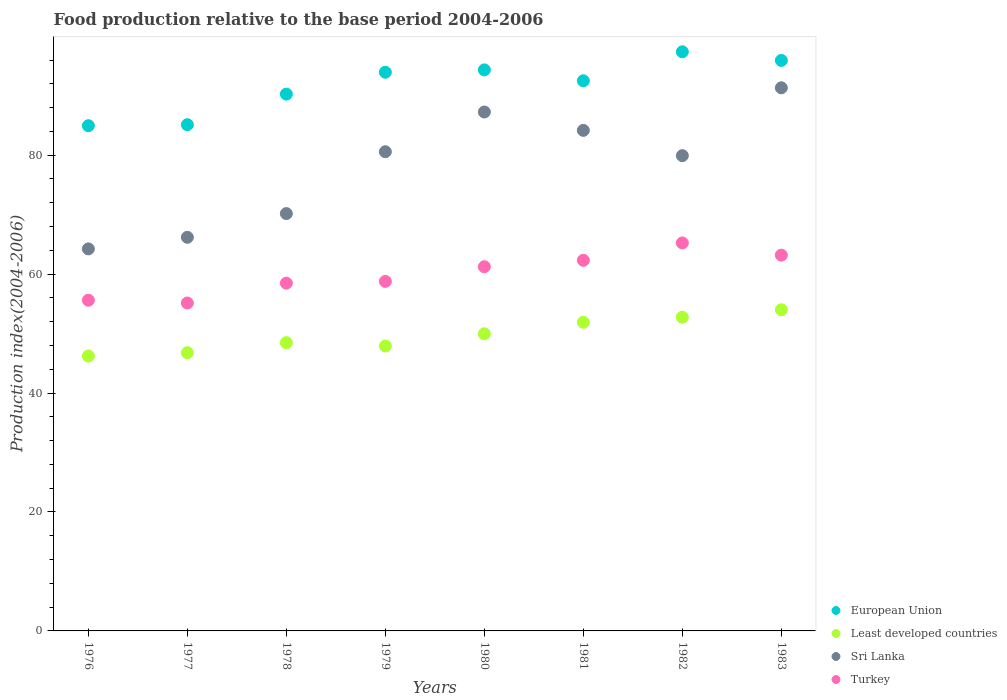How many different coloured dotlines are there?
Offer a very short reply. 4. What is the food production index in European Union in 1981?
Your answer should be compact. 92.51. Across all years, what is the maximum food production index in Least developed countries?
Make the answer very short. 54.01. Across all years, what is the minimum food production index in Turkey?
Your answer should be very brief. 55.14. In which year was the food production index in Least developed countries maximum?
Make the answer very short. 1983. In which year was the food production index in Least developed countries minimum?
Keep it short and to the point. 1976. What is the total food production index in Sri Lanka in the graph?
Your response must be concise. 623.87. What is the difference between the food production index in Turkey in 1977 and that in 1982?
Your response must be concise. -10.1. What is the difference between the food production index in Least developed countries in 1978 and the food production index in Turkey in 1977?
Provide a short and direct response. -6.67. What is the average food production index in Sri Lanka per year?
Make the answer very short. 77.98. In the year 1976, what is the difference between the food production index in Turkey and food production index in Sri Lanka?
Make the answer very short. -8.63. What is the ratio of the food production index in Sri Lanka in 1980 to that in 1983?
Offer a very short reply. 0.96. What is the difference between the highest and the second highest food production index in Sri Lanka?
Offer a terse response. 4.07. What is the difference between the highest and the lowest food production index in Least developed countries?
Ensure brevity in your answer.  7.78. Is the sum of the food production index in Least developed countries in 1976 and 1982 greater than the maximum food production index in Turkey across all years?
Offer a terse response. Yes. Is it the case that in every year, the sum of the food production index in Least developed countries and food production index in Turkey  is greater than the sum of food production index in European Union and food production index in Sri Lanka?
Offer a very short reply. No. Does the food production index in European Union monotonically increase over the years?
Provide a short and direct response. No. Is the food production index in Turkey strictly greater than the food production index in Least developed countries over the years?
Provide a succinct answer. Yes. How many years are there in the graph?
Your answer should be very brief. 8. What is the difference between two consecutive major ticks on the Y-axis?
Offer a terse response. 20. Are the values on the major ticks of Y-axis written in scientific E-notation?
Provide a short and direct response. No. How many legend labels are there?
Offer a very short reply. 4. What is the title of the graph?
Offer a very short reply. Food production relative to the base period 2004-2006. Does "Madagascar" appear as one of the legend labels in the graph?
Keep it short and to the point. No. What is the label or title of the X-axis?
Ensure brevity in your answer.  Years. What is the label or title of the Y-axis?
Your answer should be compact. Production index(2004-2006). What is the Production index(2004-2006) of European Union in 1976?
Your response must be concise. 84.96. What is the Production index(2004-2006) of Least developed countries in 1976?
Your answer should be very brief. 46.23. What is the Production index(2004-2006) of Sri Lanka in 1976?
Ensure brevity in your answer.  64.24. What is the Production index(2004-2006) of Turkey in 1976?
Give a very brief answer. 55.61. What is the Production index(2004-2006) in European Union in 1977?
Keep it short and to the point. 85.13. What is the Production index(2004-2006) in Least developed countries in 1977?
Offer a terse response. 46.79. What is the Production index(2004-2006) in Sri Lanka in 1977?
Offer a very short reply. 66.19. What is the Production index(2004-2006) of Turkey in 1977?
Offer a very short reply. 55.14. What is the Production index(2004-2006) in European Union in 1978?
Provide a succinct answer. 90.27. What is the Production index(2004-2006) of Least developed countries in 1978?
Give a very brief answer. 48.47. What is the Production index(2004-2006) of Sri Lanka in 1978?
Provide a succinct answer. 70.18. What is the Production index(2004-2006) of Turkey in 1978?
Offer a terse response. 58.48. What is the Production index(2004-2006) of European Union in 1979?
Your answer should be very brief. 93.95. What is the Production index(2004-2006) in Least developed countries in 1979?
Your response must be concise. 47.9. What is the Production index(2004-2006) in Sri Lanka in 1979?
Your answer should be very brief. 80.58. What is the Production index(2004-2006) of Turkey in 1979?
Offer a very short reply. 58.78. What is the Production index(2004-2006) in European Union in 1980?
Offer a terse response. 94.34. What is the Production index(2004-2006) in Least developed countries in 1980?
Your answer should be compact. 49.97. What is the Production index(2004-2006) of Sri Lanka in 1980?
Your answer should be compact. 87.26. What is the Production index(2004-2006) of Turkey in 1980?
Offer a terse response. 61.24. What is the Production index(2004-2006) of European Union in 1981?
Provide a short and direct response. 92.51. What is the Production index(2004-2006) in Least developed countries in 1981?
Provide a succinct answer. 51.9. What is the Production index(2004-2006) of Sri Lanka in 1981?
Offer a terse response. 84.17. What is the Production index(2004-2006) of Turkey in 1981?
Your answer should be compact. 62.32. What is the Production index(2004-2006) of European Union in 1982?
Provide a short and direct response. 97.39. What is the Production index(2004-2006) of Least developed countries in 1982?
Offer a terse response. 52.75. What is the Production index(2004-2006) in Sri Lanka in 1982?
Provide a short and direct response. 79.92. What is the Production index(2004-2006) of Turkey in 1982?
Provide a succinct answer. 65.24. What is the Production index(2004-2006) in European Union in 1983?
Give a very brief answer. 95.93. What is the Production index(2004-2006) of Least developed countries in 1983?
Offer a very short reply. 54.01. What is the Production index(2004-2006) in Sri Lanka in 1983?
Offer a terse response. 91.33. What is the Production index(2004-2006) of Turkey in 1983?
Your response must be concise. 63.19. Across all years, what is the maximum Production index(2004-2006) of European Union?
Your answer should be compact. 97.39. Across all years, what is the maximum Production index(2004-2006) in Least developed countries?
Offer a very short reply. 54.01. Across all years, what is the maximum Production index(2004-2006) in Sri Lanka?
Keep it short and to the point. 91.33. Across all years, what is the maximum Production index(2004-2006) in Turkey?
Offer a terse response. 65.24. Across all years, what is the minimum Production index(2004-2006) in European Union?
Make the answer very short. 84.96. Across all years, what is the minimum Production index(2004-2006) of Least developed countries?
Keep it short and to the point. 46.23. Across all years, what is the minimum Production index(2004-2006) in Sri Lanka?
Keep it short and to the point. 64.24. Across all years, what is the minimum Production index(2004-2006) in Turkey?
Your answer should be very brief. 55.14. What is the total Production index(2004-2006) of European Union in the graph?
Keep it short and to the point. 734.47. What is the total Production index(2004-2006) in Least developed countries in the graph?
Offer a terse response. 398.02. What is the total Production index(2004-2006) in Sri Lanka in the graph?
Your answer should be very brief. 623.87. What is the total Production index(2004-2006) of Turkey in the graph?
Provide a short and direct response. 480. What is the difference between the Production index(2004-2006) of European Union in 1976 and that in 1977?
Your answer should be compact. -0.17. What is the difference between the Production index(2004-2006) of Least developed countries in 1976 and that in 1977?
Ensure brevity in your answer.  -0.56. What is the difference between the Production index(2004-2006) in Sri Lanka in 1976 and that in 1977?
Make the answer very short. -1.95. What is the difference between the Production index(2004-2006) of Turkey in 1976 and that in 1977?
Your answer should be very brief. 0.47. What is the difference between the Production index(2004-2006) of European Union in 1976 and that in 1978?
Provide a short and direct response. -5.31. What is the difference between the Production index(2004-2006) of Least developed countries in 1976 and that in 1978?
Provide a short and direct response. -2.24. What is the difference between the Production index(2004-2006) in Sri Lanka in 1976 and that in 1978?
Your answer should be very brief. -5.94. What is the difference between the Production index(2004-2006) in Turkey in 1976 and that in 1978?
Provide a short and direct response. -2.87. What is the difference between the Production index(2004-2006) in European Union in 1976 and that in 1979?
Your answer should be very brief. -8.99. What is the difference between the Production index(2004-2006) in Least developed countries in 1976 and that in 1979?
Your answer should be very brief. -1.67. What is the difference between the Production index(2004-2006) in Sri Lanka in 1976 and that in 1979?
Ensure brevity in your answer.  -16.34. What is the difference between the Production index(2004-2006) of Turkey in 1976 and that in 1979?
Offer a terse response. -3.17. What is the difference between the Production index(2004-2006) of European Union in 1976 and that in 1980?
Provide a short and direct response. -9.39. What is the difference between the Production index(2004-2006) in Least developed countries in 1976 and that in 1980?
Give a very brief answer. -3.74. What is the difference between the Production index(2004-2006) in Sri Lanka in 1976 and that in 1980?
Keep it short and to the point. -23.02. What is the difference between the Production index(2004-2006) in Turkey in 1976 and that in 1980?
Make the answer very short. -5.63. What is the difference between the Production index(2004-2006) of European Union in 1976 and that in 1981?
Make the answer very short. -7.55. What is the difference between the Production index(2004-2006) in Least developed countries in 1976 and that in 1981?
Your response must be concise. -5.67. What is the difference between the Production index(2004-2006) of Sri Lanka in 1976 and that in 1981?
Make the answer very short. -19.93. What is the difference between the Production index(2004-2006) in Turkey in 1976 and that in 1981?
Your response must be concise. -6.71. What is the difference between the Production index(2004-2006) of European Union in 1976 and that in 1982?
Ensure brevity in your answer.  -12.43. What is the difference between the Production index(2004-2006) of Least developed countries in 1976 and that in 1982?
Your answer should be very brief. -6.52. What is the difference between the Production index(2004-2006) of Sri Lanka in 1976 and that in 1982?
Offer a very short reply. -15.68. What is the difference between the Production index(2004-2006) in Turkey in 1976 and that in 1982?
Give a very brief answer. -9.63. What is the difference between the Production index(2004-2006) of European Union in 1976 and that in 1983?
Keep it short and to the point. -10.98. What is the difference between the Production index(2004-2006) of Least developed countries in 1976 and that in 1983?
Keep it short and to the point. -7.78. What is the difference between the Production index(2004-2006) in Sri Lanka in 1976 and that in 1983?
Your answer should be very brief. -27.09. What is the difference between the Production index(2004-2006) of Turkey in 1976 and that in 1983?
Make the answer very short. -7.58. What is the difference between the Production index(2004-2006) in European Union in 1977 and that in 1978?
Provide a succinct answer. -5.14. What is the difference between the Production index(2004-2006) in Least developed countries in 1977 and that in 1978?
Make the answer very short. -1.69. What is the difference between the Production index(2004-2006) of Sri Lanka in 1977 and that in 1978?
Offer a very short reply. -3.99. What is the difference between the Production index(2004-2006) in Turkey in 1977 and that in 1978?
Give a very brief answer. -3.34. What is the difference between the Production index(2004-2006) in European Union in 1977 and that in 1979?
Your answer should be compact. -8.82. What is the difference between the Production index(2004-2006) in Least developed countries in 1977 and that in 1979?
Offer a very short reply. -1.11. What is the difference between the Production index(2004-2006) of Sri Lanka in 1977 and that in 1979?
Your response must be concise. -14.39. What is the difference between the Production index(2004-2006) in Turkey in 1977 and that in 1979?
Your answer should be very brief. -3.64. What is the difference between the Production index(2004-2006) in European Union in 1977 and that in 1980?
Offer a very short reply. -9.22. What is the difference between the Production index(2004-2006) of Least developed countries in 1977 and that in 1980?
Provide a succinct answer. -3.18. What is the difference between the Production index(2004-2006) of Sri Lanka in 1977 and that in 1980?
Provide a short and direct response. -21.07. What is the difference between the Production index(2004-2006) in Turkey in 1977 and that in 1980?
Provide a short and direct response. -6.1. What is the difference between the Production index(2004-2006) of European Union in 1977 and that in 1981?
Your answer should be compact. -7.38. What is the difference between the Production index(2004-2006) in Least developed countries in 1977 and that in 1981?
Ensure brevity in your answer.  -5.11. What is the difference between the Production index(2004-2006) of Sri Lanka in 1977 and that in 1981?
Your answer should be compact. -17.98. What is the difference between the Production index(2004-2006) in Turkey in 1977 and that in 1981?
Your answer should be very brief. -7.18. What is the difference between the Production index(2004-2006) in European Union in 1977 and that in 1982?
Give a very brief answer. -12.26. What is the difference between the Production index(2004-2006) of Least developed countries in 1977 and that in 1982?
Offer a very short reply. -5.96. What is the difference between the Production index(2004-2006) in Sri Lanka in 1977 and that in 1982?
Keep it short and to the point. -13.73. What is the difference between the Production index(2004-2006) of European Union in 1977 and that in 1983?
Your response must be concise. -10.81. What is the difference between the Production index(2004-2006) in Least developed countries in 1977 and that in 1983?
Your answer should be compact. -7.22. What is the difference between the Production index(2004-2006) in Sri Lanka in 1977 and that in 1983?
Your response must be concise. -25.14. What is the difference between the Production index(2004-2006) in Turkey in 1977 and that in 1983?
Ensure brevity in your answer.  -8.05. What is the difference between the Production index(2004-2006) in European Union in 1978 and that in 1979?
Provide a short and direct response. -3.68. What is the difference between the Production index(2004-2006) in Least developed countries in 1978 and that in 1979?
Provide a short and direct response. 0.57. What is the difference between the Production index(2004-2006) of Sri Lanka in 1978 and that in 1979?
Give a very brief answer. -10.4. What is the difference between the Production index(2004-2006) in European Union in 1978 and that in 1980?
Offer a very short reply. -4.08. What is the difference between the Production index(2004-2006) of Least developed countries in 1978 and that in 1980?
Provide a short and direct response. -1.49. What is the difference between the Production index(2004-2006) of Sri Lanka in 1978 and that in 1980?
Give a very brief answer. -17.08. What is the difference between the Production index(2004-2006) in Turkey in 1978 and that in 1980?
Give a very brief answer. -2.76. What is the difference between the Production index(2004-2006) in European Union in 1978 and that in 1981?
Ensure brevity in your answer.  -2.24. What is the difference between the Production index(2004-2006) of Least developed countries in 1978 and that in 1981?
Offer a terse response. -3.43. What is the difference between the Production index(2004-2006) in Sri Lanka in 1978 and that in 1981?
Keep it short and to the point. -13.99. What is the difference between the Production index(2004-2006) in Turkey in 1978 and that in 1981?
Your answer should be very brief. -3.84. What is the difference between the Production index(2004-2006) of European Union in 1978 and that in 1982?
Your response must be concise. -7.12. What is the difference between the Production index(2004-2006) of Least developed countries in 1978 and that in 1982?
Give a very brief answer. -4.28. What is the difference between the Production index(2004-2006) in Sri Lanka in 1978 and that in 1982?
Your answer should be very brief. -9.74. What is the difference between the Production index(2004-2006) in Turkey in 1978 and that in 1982?
Keep it short and to the point. -6.76. What is the difference between the Production index(2004-2006) of European Union in 1978 and that in 1983?
Give a very brief answer. -5.66. What is the difference between the Production index(2004-2006) in Least developed countries in 1978 and that in 1983?
Your answer should be compact. -5.53. What is the difference between the Production index(2004-2006) in Sri Lanka in 1978 and that in 1983?
Offer a very short reply. -21.15. What is the difference between the Production index(2004-2006) of Turkey in 1978 and that in 1983?
Ensure brevity in your answer.  -4.71. What is the difference between the Production index(2004-2006) in European Union in 1979 and that in 1980?
Your answer should be very brief. -0.4. What is the difference between the Production index(2004-2006) of Least developed countries in 1979 and that in 1980?
Your answer should be compact. -2.07. What is the difference between the Production index(2004-2006) of Sri Lanka in 1979 and that in 1980?
Your response must be concise. -6.68. What is the difference between the Production index(2004-2006) of Turkey in 1979 and that in 1980?
Offer a very short reply. -2.46. What is the difference between the Production index(2004-2006) of European Union in 1979 and that in 1981?
Give a very brief answer. 1.44. What is the difference between the Production index(2004-2006) of Least developed countries in 1979 and that in 1981?
Your answer should be compact. -4. What is the difference between the Production index(2004-2006) in Sri Lanka in 1979 and that in 1981?
Provide a short and direct response. -3.59. What is the difference between the Production index(2004-2006) of Turkey in 1979 and that in 1981?
Give a very brief answer. -3.54. What is the difference between the Production index(2004-2006) in European Union in 1979 and that in 1982?
Your answer should be very brief. -3.44. What is the difference between the Production index(2004-2006) of Least developed countries in 1979 and that in 1982?
Your response must be concise. -4.85. What is the difference between the Production index(2004-2006) of Sri Lanka in 1979 and that in 1982?
Provide a short and direct response. 0.66. What is the difference between the Production index(2004-2006) in Turkey in 1979 and that in 1982?
Your response must be concise. -6.46. What is the difference between the Production index(2004-2006) of European Union in 1979 and that in 1983?
Your answer should be very brief. -1.99. What is the difference between the Production index(2004-2006) of Least developed countries in 1979 and that in 1983?
Give a very brief answer. -6.11. What is the difference between the Production index(2004-2006) of Sri Lanka in 1979 and that in 1983?
Offer a terse response. -10.75. What is the difference between the Production index(2004-2006) in Turkey in 1979 and that in 1983?
Offer a very short reply. -4.41. What is the difference between the Production index(2004-2006) of European Union in 1980 and that in 1981?
Provide a short and direct response. 1.83. What is the difference between the Production index(2004-2006) in Least developed countries in 1980 and that in 1981?
Ensure brevity in your answer.  -1.93. What is the difference between the Production index(2004-2006) in Sri Lanka in 1980 and that in 1981?
Provide a short and direct response. 3.09. What is the difference between the Production index(2004-2006) of Turkey in 1980 and that in 1981?
Your answer should be compact. -1.08. What is the difference between the Production index(2004-2006) in European Union in 1980 and that in 1982?
Make the answer very short. -3.04. What is the difference between the Production index(2004-2006) of Least developed countries in 1980 and that in 1982?
Your response must be concise. -2.78. What is the difference between the Production index(2004-2006) of Sri Lanka in 1980 and that in 1982?
Your response must be concise. 7.34. What is the difference between the Production index(2004-2006) of Turkey in 1980 and that in 1982?
Your answer should be compact. -4. What is the difference between the Production index(2004-2006) of European Union in 1980 and that in 1983?
Your answer should be very brief. -1.59. What is the difference between the Production index(2004-2006) in Least developed countries in 1980 and that in 1983?
Provide a short and direct response. -4.04. What is the difference between the Production index(2004-2006) of Sri Lanka in 1980 and that in 1983?
Your answer should be very brief. -4.07. What is the difference between the Production index(2004-2006) of Turkey in 1980 and that in 1983?
Provide a succinct answer. -1.95. What is the difference between the Production index(2004-2006) in European Union in 1981 and that in 1982?
Give a very brief answer. -4.88. What is the difference between the Production index(2004-2006) of Least developed countries in 1981 and that in 1982?
Offer a very short reply. -0.85. What is the difference between the Production index(2004-2006) of Sri Lanka in 1981 and that in 1982?
Make the answer very short. 4.25. What is the difference between the Production index(2004-2006) of Turkey in 1981 and that in 1982?
Make the answer very short. -2.92. What is the difference between the Production index(2004-2006) in European Union in 1981 and that in 1983?
Provide a succinct answer. -3.42. What is the difference between the Production index(2004-2006) in Least developed countries in 1981 and that in 1983?
Make the answer very short. -2.11. What is the difference between the Production index(2004-2006) of Sri Lanka in 1981 and that in 1983?
Offer a very short reply. -7.16. What is the difference between the Production index(2004-2006) in Turkey in 1981 and that in 1983?
Your answer should be compact. -0.87. What is the difference between the Production index(2004-2006) of European Union in 1982 and that in 1983?
Your answer should be very brief. 1.45. What is the difference between the Production index(2004-2006) of Least developed countries in 1982 and that in 1983?
Ensure brevity in your answer.  -1.26. What is the difference between the Production index(2004-2006) in Sri Lanka in 1982 and that in 1983?
Give a very brief answer. -11.41. What is the difference between the Production index(2004-2006) in Turkey in 1982 and that in 1983?
Offer a terse response. 2.05. What is the difference between the Production index(2004-2006) of European Union in 1976 and the Production index(2004-2006) of Least developed countries in 1977?
Your response must be concise. 38.17. What is the difference between the Production index(2004-2006) of European Union in 1976 and the Production index(2004-2006) of Sri Lanka in 1977?
Your answer should be very brief. 18.77. What is the difference between the Production index(2004-2006) of European Union in 1976 and the Production index(2004-2006) of Turkey in 1977?
Ensure brevity in your answer.  29.82. What is the difference between the Production index(2004-2006) of Least developed countries in 1976 and the Production index(2004-2006) of Sri Lanka in 1977?
Make the answer very short. -19.96. What is the difference between the Production index(2004-2006) of Least developed countries in 1976 and the Production index(2004-2006) of Turkey in 1977?
Your answer should be compact. -8.91. What is the difference between the Production index(2004-2006) of Sri Lanka in 1976 and the Production index(2004-2006) of Turkey in 1977?
Keep it short and to the point. 9.1. What is the difference between the Production index(2004-2006) of European Union in 1976 and the Production index(2004-2006) of Least developed countries in 1978?
Make the answer very short. 36.48. What is the difference between the Production index(2004-2006) of European Union in 1976 and the Production index(2004-2006) of Sri Lanka in 1978?
Make the answer very short. 14.78. What is the difference between the Production index(2004-2006) of European Union in 1976 and the Production index(2004-2006) of Turkey in 1978?
Offer a terse response. 26.48. What is the difference between the Production index(2004-2006) of Least developed countries in 1976 and the Production index(2004-2006) of Sri Lanka in 1978?
Ensure brevity in your answer.  -23.95. What is the difference between the Production index(2004-2006) of Least developed countries in 1976 and the Production index(2004-2006) of Turkey in 1978?
Give a very brief answer. -12.25. What is the difference between the Production index(2004-2006) of Sri Lanka in 1976 and the Production index(2004-2006) of Turkey in 1978?
Your response must be concise. 5.76. What is the difference between the Production index(2004-2006) of European Union in 1976 and the Production index(2004-2006) of Least developed countries in 1979?
Your answer should be very brief. 37.06. What is the difference between the Production index(2004-2006) in European Union in 1976 and the Production index(2004-2006) in Sri Lanka in 1979?
Offer a very short reply. 4.38. What is the difference between the Production index(2004-2006) in European Union in 1976 and the Production index(2004-2006) in Turkey in 1979?
Provide a succinct answer. 26.18. What is the difference between the Production index(2004-2006) in Least developed countries in 1976 and the Production index(2004-2006) in Sri Lanka in 1979?
Offer a very short reply. -34.35. What is the difference between the Production index(2004-2006) of Least developed countries in 1976 and the Production index(2004-2006) of Turkey in 1979?
Provide a short and direct response. -12.55. What is the difference between the Production index(2004-2006) of Sri Lanka in 1976 and the Production index(2004-2006) of Turkey in 1979?
Offer a terse response. 5.46. What is the difference between the Production index(2004-2006) of European Union in 1976 and the Production index(2004-2006) of Least developed countries in 1980?
Make the answer very short. 34.99. What is the difference between the Production index(2004-2006) of European Union in 1976 and the Production index(2004-2006) of Sri Lanka in 1980?
Make the answer very short. -2.3. What is the difference between the Production index(2004-2006) of European Union in 1976 and the Production index(2004-2006) of Turkey in 1980?
Offer a terse response. 23.72. What is the difference between the Production index(2004-2006) in Least developed countries in 1976 and the Production index(2004-2006) in Sri Lanka in 1980?
Provide a succinct answer. -41.03. What is the difference between the Production index(2004-2006) in Least developed countries in 1976 and the Production index(2004-2006) in Turkey in 1980?
Your response must be concise. -15.01. What is the difference between the Production index(2004-2006) in Sri Lanka in 1976 and the Production index(2004-2006) in Turkey in 1980?
Ensure brevity in your answer.  3. What is the difference between the Production index(2004-2006) of European Union in 1976 and the Production index(2004-2006) of Least developed countries in 1981?
Offer a terse response. 33.06. What is the difference between the Production index(2004-2006) in European Union in 1976 and the Production index(2004-2006) in Sri Lanka in 1981?
Your response must be concise. 0.79. What is the difference between the Production index(2004-2006) in European Union in 1976 and the Production index(2004-2006) in Turkey in 1981?
Give a very brief answer. 22.64. What is the difference between the Production index(2004-2006) in Least developed countries in 1976 and the Production index(2004-2006) in Sri Lanka in 1981?
Your response must be concise. -37.94. What is the difference between the Production index(2004-2006) in Least developed countries in 1976 and the Production index(2004-2006) in Turkey in 1981?
Give a very brief answer. -16.09. What is the difference between the Production index(2004-2006) of Sri Lanka in 1976 and the Production index(2004-2006) of Turkey in 1981?
Ensure brevity in your answer.  1.92. What is the difference between the Production index(2004-2006) in European Union in 1976 and the Production index(2004-2006) in Least developed countries in 1982?
Provide a succinct answer. 32.21. What is the difference between the Production index(2004-2006) of European Union in 1976 and the Production index(2004-2006) of Sri Lanka in 1982?
Provide a succinct answer. 5.04. What is the difference between the Production index(2004-2006) in European Union in 1976 and the Production index(2004-2006) in Turkey in 1982?
Offer a terse response. 19.72. What is the difference between the Production index(2004-2006) in Least developed countries in 1976 and the Production index(2004-2006) in Sri Lanka in 1982?
Give a very brief answer. -33.69. What is the difference between the Production index(2004-2006) of Least developed countries in 1976 and the Production index(2004-2006) of Turkey in 1982?
Offer a terse response. -19.01. What is the difference between the Production index(2004-2006) of European Union in 1976 and the Production index(2004-2006) of Least developed countries in 1983?
Make the answer very short. 30.95. What is the difference between the Production index(2004-2006) in European Union in 1976 and the Production index(2004-2006) in Sri Lanka in 1983?
Keep it short and to the point. -6.37. What is the difference between the Production index(2004-2006) in European Union in 1976 and the Production index(2004-2006) in Turkey in 1983?
Offer a very short reply. 21.77. What is the difference between the Production index(2004-2006) of Least developed countries in 1976 and the Production index(2004-2006) of Sri Lanka in 1983?
Offer a terse response. -45.1. What is the difference between the Production index(2004-2006) of Least developed countries in 1976 and the Production index(2004-2006) of Turkey in 1983?
Keep it short and to the point. -16.96. What is the difference between the Production index(2004-2006) of European Union in 1977 and the Production index(2004-2006) of Least developed countries in 1978?
Give a very brief answer. 36.65. What is the difference between the Production index(2004-2006) of European Union in 1977 and the Production index(2004-2006) of Sri Lanka in 1978?
Your response must be concise. 14.95. What is the difference between the Production index(2004-2006) in European Union in 1977 and the Production index(2004-2006) in Turkey in 1978?
Provide a succinct answer. 26.65. What is the difference between the Production index(2004-2006) in Least developed countries in 1977 and the Production index(2004-2006) in Sri Lanka in 1978?
Keep it short and to the point. -23.39. What is the difference between the Production index(2004-2006) of Least developed countries in 1977 and the Production index(2004-2006) of Turkey in 1978?
Offer a very short reply. -11.69. What is the difference between the Production index(2004-2006) of Sri Lanka in 1977 and the Production index(2004-2006) of Turkey in 1978?
Your response must be concise. 7.71. What is the difference between the Production index(2004-2006) of European Union in 1977 and the Production index(2004-2006) of Least developed countries in 1979?
Offer a terse response. 37.23. What is the difference between the Production index(2004-2006) of European Union in 1977 and the Production index(2004-2006) of Sri Lanka in 1979?
Offer a very short reply. 4.55. What is the difference between the Production index(2004-2006) of European Union in 1977 and the Production index(2004-2006) of Turkey in 1979?
Provide a succinct answer. 26.35. What is the difference between the Production index(2004-2006) in Least developed countries in 1977 and the Production index(2004-2006) in Sri Lanka in 1979?
Provide a succinct answer. -33.79. What is the difference between the Production index(2004-2006) in Least developed countries in 1977 and the Production index(2004-2006) in Turkey in 1979?
Make the answer very short. -11.99. What is the difference between the Production index(2004-2006) of Sri Lanka in 1977 and the Production index(2004-2006) of Turkey in 1979?
Offer a terse response. 7.41. What is the difference between the Production index(2004-2006) in European Union in 1977 and the Production index(2004-2006) in Least developed countries in 1980?
Provide a succinct answer. 35.16. What is the difference between the Production index(2004-2006) in European Union in 1977 and the Production index(2004-2006) in Sri Lanka in 1980?
Your response must be concise. -2.13. What is the difference between the Production index(2004-2006) in European Union in 1977 and the Production index(2004-2006) in Turkey in 1980?
Give a very brief answer. 23.89. What is the difference between the Production index(2004-2006) of Least developed countries in 1977 and the Production index(2004-2006) of Sri Lanka in 1980?
Give a very brief answer. -40.47. What is the difference between the Production index(2004-2006) in Least developed countries in 1977 and the Production index(2004-2006) in Turkey in 1980?
Your response must be concise. -14.45. What is the difference between the Production index(2004-2006) of Sri Lanka in 1977 and the Production index(2004-2006) of Turkey in 1980?
Give a very brief answer. 4.95. What is the difference between the Production index(2004-2006) of European Union in 1977 and the Production index(2004-2006) of Least developed countries in 1981?
Your response must be concise. 33.23. What is the difference between the Production index(2004-2006) in European Union in 1977 and the Production index(2004-2006) in Sri Lanka in 1981?
Offer a very short reply. 0.96. What is the difference between the Production index(2004-2006) of European Union in 1977 and the Production index(2004-2006) of Turkey in 1981?
Keep it short and to the point. 22.81. What is the difference between the Production index(2004-2006) of Least developed countries in 1977 and the Production index(2004-2006) of Sri Lanka in 1981?
Make the answer very short. -37.38. What is the difference between the Production index(2004-2006) of Least developed countries in 1977 and the Production index(2004-2006) of Turkey in 1981?
Give a very brief answer. -15.53. What is the difference between the Production index(2004-2006) in Sri Lanka in 1977 and the Production index(2004-2006) in Turkey in 1981?
Your answer should be compact. 3.87. What is the difference between the Production index(2004-2006) of European Union in 1977 and the Production index(2004-2006) of Least developed countries in 1982?
Offer a very short reply. 32.38. What is the difference between the Production index(2004-2006) in European Union in 1977 and the Production index(2004-2006) in Sri Lanka in 1982?
Provide a succinct answer. 5.21. What is the difference between the Production index(2004-2006) of European Union in 1977 and the Production index(2004-2006) of Turkey in 1982?
Offer a terse response. 19.89. What is the difference between the Production index(2004-2006) in Least developed countries in 1977 and the Production index(2004-2006) in Sri Lanka in 1982?
Provide a short and direct response. -33.13. What is the difference between the Production index(2004-2006) in Least developed countries in 1977 and the Production index(2004-2006) in Turkey in 1982?
Make the answer very short. -18.45. What is the difference between the Production index(2004-2006) of European Union in 1977 and the Production index(2004-2006) of Least developed countries in 1983?
Ensure brevity in your answer.  31.12. What is the difference between the Production index(2004-2006) in European Union in 1977 and the Production index(2004-2006) in Sri Lanka in 1983?
Offer a very short reply. -6.2. What is the difference between the Production index(2004-2006) of European Union in 1977 and the Production index(2004-2006) of Turkey in 1983?
Ensure brevity in your answer.  21.94. What is the difference between the Production index(2004-2006) of Least developed countries in 1977 and the Production index(2004-2006) of Sri Lanka in 1983?
Your answer should be compact. -44.54. What is the difference between the Production index(2004-2006) of Least developed countries in 1977 and the Production index(2004-2006) of Turkey in 1983?
Offer a very short reply. -16.4. What is the difference between the Production index(2004-2006) of Sri Lanka in 1977 and the Production index(2004-2006) of Turkey in 1983?
Your answer should be compact. 3. What is the difference between the Production index(2004-2006) of European Union in 1978 and the Production index(2004-2006) of Least developed countries in 1979?
Give a very brief answer. 42.37. What is the difference between the Production index(2004-2006) in European Union in 1978 and the Production index(2004-2006) in Sri Lanka in 1979?
Keep it short and to the point. 9.69. What is the difference between the Production index(2004-2006) of European Union in 1978 and the Production index(2004-2006) of Turkey in 1979?
Offer a very short reply. 31.49. What is the difference between the Production index(2004-2006) in Least developed countries in 1978 and the Production index(2004-2006) in Sri Lanka in 1979?
Make the answer very short. -32.11. What is the difference between the Production index(2004-2006) of Least developed countries in 1978 and the Production index(2004-2006) of Turkey in 1979?
Your answer should be very brief. -10.31. What is the difference between the Production index(2004-2006) of Sri Lanka in 1978 and the Production index(2004-2006) of Turkey in 1979?
Make the answer very short. 11.4. What is the difference between the Production index(2004-2006) of European Union in 1978 and the Production index(2004-2006) of Least developed countries in 1980?
Ensure brevity in your answer.  40.3. What is the difference between the Production index(2004-2006) in European Union in 1978 and the Production index(2004-2006) in Sri Lanka in 1980?
Your response must be concise. 3.01. What is the difference between the Production index(2004-2006) in European Union in 1978 and the Production index(2004-2006) in Turkey in 1980?
Provide a succinct answer. 29.03. What is the difference between the Production index(2004-2006) in Least developed countries in 1978 and the Production index(2004-2006) in Sri Lanka in 1980?
Give a very brief answer. -38.79. What is the difference between the Production index(2004-2006) in Least developed countries in 1978 and the Production index(2004-2006) in Turkey in 1980?
Offer a terse response. -12.77. What is the difference between the Production index(2004-2006) of Sri Lanka in 1978 and the Production index(2004-2006) of Turkey in 1980?
Ensure brevity in your answer.  8.94. What is the difference between the Production index(2004-2006) of European Union in 1978 and the Production index(2004-2006) of Least developed countries in 1981?
Your answer should be very brief. 38.37. What is the difference between the Production index(2004-2006) of European Union in 1978 and the Production index(2004-2006) of Sri Lanka in 1981?
Your answer should be compact. 6.1. What is the difference between the Production index(2004-2006) of European Union in 1978 and the Production index(2004-2006) of Turkey in 1981?
Make the answer very short. 27.95. What is the difference between the Production index(2004-2006) of Least developed countries in 1978 and the Production index(2004-2006) of Sri Lanka in 1981?
Provide a succinct answer. -35.7. What is the difference between the Production index(2004-2006) of Least developed countries in 1978 and the Production index(2004-2006) of Turkey in 1981?
Ensure brevity in your answer.  -13.85. What is the difference between the Production index(2004-2006) in Sri Lanka in 1978 and the Production index(2004-2006) in Turkey in 1981?
Ensure brevity in your answer.  7.86. What is the difference between the Production index(2004-2006) of European Union in 1978 and the Production index(2004-2006) of Least developed countries in 1982?
Provide a short and direct response. 37.52. What is the difference between the Production index(2004-2006) of European Union in 1978 and the Production index(2004-2006) of Sri Lanka in 1982?
Offer a terse response. 10.35. What is the difference between the Production index(2004-2006) of European Union in 1978 and the Production index(2004-2006) of Turkey in 1982?
Keep it short and to the point. 25.03. What is the difference between the Production index(2004-2006) in Least developed countries in 1978 and the Production index(2004-2006) in Sri Lanka in 1982?
Provide a succinct answer. -31.45. What is the difference between the Production index(2004-2006) of Least developed countries in 1978 and the Production index(2004-2006) of Turkey in 1982?
Give a very brief answer. -16.77. What is the difference between the Production index(2004-2006) in Sri Lanka in 1978 and the Production index(2004-2006) in Turkey in 1982?
Provide a succinct answer. 4.94. What is the difference between the Production index(2004-2006) of European Union in 1978 and the Production index(2004-2006) of Least developed countries in 1983?
Offer a terse response. 36.26. What is the difference between the Production index(2004-2006) in European Union in 1978 and the Production index(2004-2006) in Sri Lanka in 1983?
Make the answer very short. -1.06. What is the difference between the Production index(2004-2006) of European Union in 1978 and the Production index(2004-2006) of Turkey in 1983?
Give a very brief answer. 27.08. What is the difference between the Production index(2004-2006) in Least developed countries in 1978 and the Production index(2004-2006) in Sri Lanka in 1983?
Your answer should be compact. -42.86. What is the difference between the Production index(2004-2006) in Least developed countries in 1978 and the Production index(2004-2006) in Turkey in 1983?
Make the answer very short. -14.72. What is the difference between the Production index(2004-2006) in Sri Lanka in 1978 and the Production index(2004-2006) in Turkey in 1983?
Give a very brief answer. 6.99. What is the difference between the Production index(2004-2006) in European Union in 1979 and the Production index(2004-2006) in Least developed countries in 1980?
Your response must be concise. 43.98. What is the difference between the Production index(2004-2006) of European Union in 1979 and the Production index(2004-2006) of Sri Lanka in 1980?
Give a very brief answer. 6.69. What is the difference between the Production index(2004-2006) in European Union in 1979 and the Production index(2004-2006) in Turkey in 1980?
Your response must be concise. 32.71. What is the difference between the Production index(2004-2006) in Least developed countries in 1979 and the Production index(2004-2006) in Sri Lanka in 1980?
Provide a short and direct response. -39.36. What is the difference between the Production index(2004-2006) in Least developed countries in 1979 and the Production index(2004-2006) in Turkey in 1980?
Your answer should be very brief. -13.34. What is the difference between the Production index(2004-2006) of Sri Lanka in 1979 and the Production index(2004-2006) of Turkey in 1980?
Your response must be concise. 19.34. What is the difference between the Production index(2004-2006) in European Union in 1979 and the Production index(2004-2006) in Least developed countries in 1981?
Your answer should be very brief. 42.05. What is the difference between the Production index(2004-2006) of European Union in 1979 and the Production index(2004-2006) of Sri Lanka in 1981?
Make the answer very short. 9.78. What is the difference between the Production index(2004-2006) of European Union in 1979 and the Production index(2004-2006) of Turkey in 1981?
Your answer should be very brief. 31.63. What is the difference between the Production index(2004-2006) of Least developed countries in 1979 and the Production index(2004-2006) of Sri Lanka in 1981?
Offer a very short reply. -36.27. What is the difference between the Production index(2004-2006) in Least developed countries in 1979 and the Production index(2004-2006) in Turkey in 1981?
Your response must be concise. -14.42. What is the difference between the Production index(2004-2006) of Sri Lanka in 1979 and the Production index(2004-2006) of Turkey in 1981?
Your answer should be very brief. 18.26. What is the difference between the Production index(2004-2006) of European Union in 1979 and the Production index(2004-2006) of Least developed countries in 1982?
Provide a short and direct response. 41.2. What is the difference between the Production index(2004-2006) in European Union in 1979 and the Production index(2004-2006) in Sri Lanka in 1982?
Your response must be concise. 14.03. What is the difference between the Production index(2004-2006) of European Union in 1979 and the Production index(2004-2006) of Turkey in 1982?
Keep it short and to the point. 28.71. What is the difference between the Production index(2004-2006) in Least developed countries in 1979 and the Production index(2004-2006) in Sri Lanka in 1982?
Your answer should be compact. -32.02. What is the difference between the Production index(2004-2006) of Least developed countries in 1979 and the Production index(2004-2006) of Turkey in 1982?
Provide a short and direct response. -17.34. What is the difference between the Production index(2004-2006) in Sri Lanka in 1979 and the Production index(2004-2006) in Turkey in 1982?
Provide a short and direct response. 15.34. What is the difference between the Production index(2004-2006) in European Union in 1979 and the Production index(2004-2006) in Least developed countries in 1983?
Provide a succinct answer. 39.94. What is the difference between the Production index(2004-2006) in European Union in 1979 and the Production index(2004-2006) in Sri Lanka in 1983?
Make the answer very short. 2.62. What is the difference between the Production index(2004-2006) in European Union in 1979 and the Production index(2004-2006) in Turkey in 1983?
Your answer should be very brief. 30.76. What is the difference between the Production index(2004-2006) of Least developed countries in 1979 and the Production index(2004-2006) of Sri Lanka in 1983?
Offer a very short reply. -43.43. What is the difference between the Production index(2004-2006) in Least developed countries in 1979 and the Production index(2004-2006) in Turkey in 1983?
Your response must be concise. -15.29. What is the difference between the Production index(2004-2006) in Sri Lanka in 1979 and the Production index(2004-2006) in Turkey in 1983?
Give a very brief answer. 17.39. What is the difference between the Production index(2004-2006) in European Union in 1980 and the Production index(2004-2006) in Least developed countries in 1981?
Keep it short and to the point. 42.44. What is the difference between the Production index(2004-2006) in European Union in 1980 and the Production index(2004-2006) in Sri Lanka in 1981?
Your response must be concise. 10.17. What is the difference between the Production index(2004-2006) of European Union in 1980 and the Production index(2004-2006) of Turkey in 1981?
Keep it short and to the point. 32.02. What is the difference between the Production index(2004-2006) in Least developed countries in 1980 and the Production index(2004-2006) in Sri Lanka in 1981?
Ensure brevity in your answer.  -34.2. What is the difference between the Production index(2004-2006) of Least developed countries in 1980 and the Production index(2004-2006) of Turkey in 1981?
Your response must be concise. -12.35. What is the difference between the Production index(2004-2006) in Sri Lanka in 1980 and the Production index(2004-2006) in Turkey in 1981?
Provide a succinct answer. 24.94. What is the difference between the Production index(2004-2006) in European Union in 1980 and the Production index(2004-2006) in Least developed countries in 1982?
Provide a short and direct response. 41.59. What is the difference between the Production index(2004-2006) in European Union in 1980 and the Production index(2004-2006) in Sri Lanka in 1982?
Your response must be concise. 14.42. What is the difference between the Production index(2004-2006) in European Union in 1980 and the Production index(2004-2006) in Turkey in 1982?
Provide a short and direct response. 29.1. What is the difference between the Production index(2004-2006) in Least developed countries in 1980 and the Production index(2004-2006) in Sri Lanka in 1982?
Your answer should be very brief. -29.95. What is the difference between the Production index(2004-2006) in Least developed countries in 1980 and the Production index(2004-2006) in Turkey in 1982?
Keep it short and to the point. -15.27. What is the difference between the Production index(2004-2006) in Sri Lanka in 1980 and the Production index(2004-2006) in Turkey in 1982?
Provide a short and direct response. 22.02. What is the difference between the Production index(2004-2006) in European Union in 1980 and the Production index(2004-2006) in Least developed countries in 1983?
Your response must be concise. 40.34. What is the difference between the Production index(2004-2006) in European Union in 1980 and the Production index(2004-2006) in Sri Lanka in 1983?
Your answer should be very brief. 3.01. What is the difference between the Production index(2004-2006) of European Union in 1980 and the Production index(2004-2006) of Turkey in 1983?
Give a very brief answer. 31.15. What is the difference between the Production index(2004-2006) in Least developed countries in 1980 and the Production index(2004-2006) in Sri Lanka in 1983?
Ensure brevity in your answer.  -41.36. What is the difference between the Production index(2004-2006) in Least developed countries in 1980 and the Production index(2004-2006) in Turkey in 1983?
Your response must be concise. -13.22. What is the difference between the Production index(2004-2006) of Sri Lanka in 1980 and the Production index(2004-2006) of Turkey in 1983?
Keep it short and to the point. 24.07. What is the difference between the Production index(2004-2006) in European Union in 1981 and the Production index(2004-2006) in Least developed countries in 1982?
Provide a succinct answer. 39.76. What is the difference between the Production index(2004-2006) of European Union in 1981 and the Production index(2004-2006) of Sri Lanka in 1982?
Provide a short and direct response. 12.59. What is the difference between the Production index(2004-2006) in European Union in 1981 and the Production index(2004-2006) in Turkey in 1982?
Your answer should be very brief. 27.27. What is the difference between the Production index(2004-2006) in Least developed countries in 1981 and the Production index(2004-2006) in Sri Lanka in 1982?
Provide a succinct answer. -28.02. What is the difference between the Production index(2004-2006) of Least developed countries in 1981 and the Production index(2004-2006) of Turkey in 1982?
Your response must be concise. -13.34. What is the difference between the Production index(2004-2006) in Sri Lanka in 1981 and the Production index(2004-2006) in Turkey in 1982?
Ensure brevity in your answer.  18.93. What is the difference between the Production index(2004-2006) of European Union in 1981 and the Production index(2004-2006) of Least developed countries in 1983?
Provide a succinct answer. 38.5. What is the difference between the Production index(2004-2006) of European Union in 1981 and the Production index(2004-2006) of Sri Lanka in 1983?
Your answer should be compact. 1.18. What is the difference between the Production index(2004-2006) of European Union in 1981 and the Production index(2004-2006) of Turkey in 1983?
Provide a succinct answer. 29.32. What is the difference between the Production index(2004-2006) of Least developed countries in 1981 and the Production index(2004-2006) of Sri Lanka in 1983?
Offer a terse response. -39.43. What is the difference between the Production index(2004-2006) in Least developed countries in 1981 and the Production index(2004-2006) in Turkey in 1983?
Provide a short and direct response. -11.29. What is the difference between the Production index(2004-2006) in Sri Lanka in 1981 and the Production index(2004-2006) in Turkey in 1983?
Make the answer very short. 20.98. What is the difference between the Production index(2004-2006) in European Union in 1982 and the Production index(2004-2006) in Least developed countries in 1983?
Offer a terse response. 43.38. What is the difference between the Production index(2004-2006) in European Union in 1982 and the Production index(2004-2006) in Sri Lanka in 1983?
Your response must be concise. 6.06. What is the difference between the Production index(2004-2006) of European Union in 1982 and the Production index(2004-2006) of Turkey in 1983?
Ensure brevity in your answer.  34.2. What is the difference between the Production index(2004-2006) in Least developed countries in 1982 and the Production index(2004-2006) in Sri Lanka in 1983?
Your response must be concise. -38.58. What is the difference between the Production index(2004-2006) of Least developed countries in 1982 and the Production index(2004-2006) of Turkey in 1983?
Your answer should be very brief. -10.44. What is the difference between the Production index(2004-2006) in Sri Lanka in 1982 and the Production index(2004-2006) in Turkey in 1983?
Keep it short and to the point. 16.73. What is the average Production index(2004-2006) of European Union per year?
Offer a very short reply. 91.81. What is the average Production index(2004-2006) in Least developed countries per year?
Offer a terse response. 49.75. What is the average Production index(2004-2006) of Sri Lanka per year?
Ensure brevity in your answer.  77.98. What is the average Production index(2004-2006) in Turkey per year?
Provide a short and direct response. 60. In the year 1976, what is the difference between the Production index(2004-2006) of European Union and Production index(2004-2006) of Least developed countries?
Give a very brief answer. 38.73. In the year 1976, what is the difference between the Production index(2004-2006) in European Union and Production index(2004-2006) in Sri Lanka?
Give a very brief answer. 20.72. In the year 1976, what is the difference between the Production index(2004-2006) of European Union and Production index(2004-2006) of Turkey?
Give a very brief answer. 29.35. In the year 1976, what is the difference between the Production index(2004-2006) in Least developed countries and Production index(2004-2006) in Sri Lanka?
Keep it short and to the point. -18.01. In the year 1976, what is the difference between the Production index(2004-2006) in Least developed countries and Production index(2004-2006) in Turkey?
Keep it short and to the point. -9.38. In the year 1976, what is the difference between the Production index(2004-2006) in Sri Lanka and Production index(2004-2006) in Turkey?
Offer a terse response. 8.63. In the year 1977, what is the difference between the Production index(2004-2006) of European Union and Production index(2004-2006) of Least developed countries?
Give a very brief answer. 38.34. In the year 1977, what is the difference between the Production index(2004-2006) of European Union and Production index(2004-2006) of Sri Lanka?
Your answer should be very brief. 18.94. In the year 1977, what is the difference between the Production index(2004-2006) in European Union and Production index(2004-2006) in Turkey?
Offer a terse response. 29.99. In the year 1977, what is the difference between the Production index(2004-2006) of Least developed countries and Production index(2004-2006) of Sri Lanka?
Provide a succinct answer. -19.4. In the year 1977, what is the difference between the Production index(2004-2006) in Least developed countries and Production index(2004-2006) in Turkey?
Give a very brief answer. -8.35. In the year 1977, what is the difference between the Production index(2004-2006) in Sri Lanka and Production index(2004-2006) in Turkey?
Your answer should be very brief. 11.05. In the year 1978, what is the difference between the Production index(2004-2006) of European Union and Production index(2004-2006) of Least developed countries?
Your response must be concise. 41.79. In the year 1978, what is the difference between the Production index(2004-2006) of European Union and Production index(2004-2006) of Sri Lanka?
Ensure brevity in your answer.  20.09. In the year 1978, what is the difference between the Production index(2004-2006) of European Union and Production index(2004-2006) of Turkey?
Your answer should be compact. 31.79. In the year 1978, what is the difference between the Production index(2004-2006) of Least developed countries and Production index(2004-2006) of Sri Lanka?
Ensure brevity in your answer.  -21.71. In the year 1978, what is the difference between the Production index(2004-2006) of Least developed countries and Production index(2004-2006) of Turkey?
Give a very brief answer. -10.01. In the year 1979, what is the difference between the Production index(2004-2006) in European Union and Production index(2004-2006) in Least developed countries?
Ensure brevity in your answer.  46.05. In the year 1979, what is the difference between the Production index(2004-2006) in European Union and Production index(2004-2006) in Sri Lanka?
Offer a terse response. 13.37. In the year 1979, what is the difference between the Production index(2004-2006) of European Union and Production index(2004-2006) of Turkey?
Make the answer very short. 35.17. In the year 1979, what is the difference between the Production index(2004-2006) of Least developed countries and Production index(2004-2006) of Sri Lanka?
Keep it short and to the point. -32.68. In the year 1979, what is the difference between the Production index(2004-2006) in Least developed countries and Production index(2004-2006) in Turkey?
Offer a very short reply. -10.88. In the year 1979, what is the difference between the Production index(2004-2006) in Sri Lanka and Production index(2004-2006) in Turkey?
Your answer should be very brief. 21.8. In the year 1980, what is the difference between the Production index(2004-2006) in European Union and Production index(2004-2006) in Least developed countries?
Offer a very short reply. 44.38. In the year 1980, what is the difference between the Production index(2004-2006) of European Union and Production index(2004-2006) of Sri Lanka?
Provide a short and direct response. 7.08. In the year 1980, what is the difference between the Production index(2004-2006) in European Union and Production index(2004-2006) in Turkey?
Ensure brevity in your answer.  33.1. In the year 1980, what is the difference between the Production index(2004-2006) in Least developed countries and Production index(2004-2006) in Sri Lanka?
Provide a short and direct response. -37.29. In the year 1980, what is the difference between the Production index(2004-2006) of Least developed countries and Production index(2004-2006) of Turkey?
Your answer should be very brief. -11.27. In the year 1980, what is the difference between the Production index(2004-2006) in Sri Lanka and Production index(2004-2006) in Turkey?
Give a very brief answer. 26.02. In the year 1981, what is the difference between the Production index(2004-2006) in European Union and Production index(2004-2006) in Least developed countries?
Offer a very short reply. 40.61. In the year 1981, what is the difference between the Production index(2004-2006) of European Union and Production index(2004-2006) of Sri Lanka?
Your answer should be very brief. 8.34. In the year 1981, what is the difference between the Production index(2004-2006) of European Union and Production index(2004-2006) of Turkey?
Offer a very short reply. 30.19. In the year 1981, what is the difference between the Production index(2004-2006) of Least developed countries and Production index(2004-2006) of Sri Lanka?
Ensure brevity in your answer.  -32.27. In the year 1981, what is the difference between the Production index(2004-2006) in Least developed countries and Production index(2004-2006) in Turkey?
Your answer should be very brief. -10.42. In the year 1981, what is the difference between the Production index(2004-2006) of Sri Lanka and Production index(2004-2006) of Turkey?
Make the answer very short. 21.85. In the year 1982, what is the difference between the Production index(2004-2006) of European Union and Production index(2004-2006) of Least developed countries?
Make the answer very short. 44.64. In the year 1982, what is the difference between the Production index(2004-2006) of European Union and Production index(2004-2006) of Sri Lanka?
Offer a very short reply. 17.47. In the year 1982, what is the difference between the Production index(2004-2006) in European Union and Production index(2004-2006) in Turkey?
Keep it short and to the point. 32.15. In the year 1982, what is the difference between the Production index(2004-2006) in Least developed countries and Production index(2004-2006) in Sri Lanka?
Provide a short and direct response. -27.17. In the year 1982, what is the difference between the Production index(2004-2006) of Least developed countries and Production index(2004-2006) of Turkey?
Keep it short and to the point. -12.49. In the year 1982, what is the difference between the Production index(2004-2006) of Sri Lanka and Production index(2004-2006) of Turkey?
Offer a very short reply. 14.68. In the year 1983, what is the difference between the Production index(2004-2006) in European Union and Production index(2004-2006) in Least developed countries?
Offer a very short reply. 41.93. In the year 1983, what is the difference between the Production index(2004-2006) of European Union and Production index(2004-2006) of Sri Lanka?
Offer a very short reply. 4.6. In the year 1983, what is the difference between the Production index(2004-2006) of European Union and Production index(2004-2006) of Turkey?
Provide a short and direct response. 32.74. In the year 1983, what is the difference between the Production index(2004-2006) of Least developed countries and Production index(2004-2006) of Sri Lanka?
Ensure brevity in your answer.  -37.32. In the year 1983, what is the difference between the Production index(2004-2006) of Least developed countries and Production index(2004-2006) of Turkey?
Make the answer very short. -9.18. In the year 1983, what is the difference between the Production index(2004-2006) in Sri Lanka and Production index(2004-2006) in Turkey?
Keep it short and to the point. 28.14. What is the ratio of the Production index(2004-2006) in European Union in 1976 to that in 1977?
Make the answer very short. 1. What is the ratio of the Production index(2004-2006) in Sri Lanka in 1976 to that in 1977?
Give a very brief answer. 0.97. What is the ratio of the Production index(2004-2006) in Turkey in 1976 to that in 1977?
Your response must be concise. 1.01. What is the ratio of the Production index(2004-2006) in European Union in 1976 to that in 1978?
Offer a terse response. 0.94. What is the ratio of the Production index(2004-2006) of Least developed countries in 1976 to that in 1978?
Provide a succinct answer. 0.95. What is the ratio of the Production index(2004-2006) of Sri Lanka in 1976 to that in 1978?
Your answer should be very brief. 0.92. What is the ratio of the Production index(2004-2006) of Turkey in 1976 to that in 1978?
Offer a very short reply. 0.95. What is the ratio of the Production index(2004-2006) of European Union in 1976 to that in 1979?
Offer a terse response. 0.9. What is the ratio of the Production index(2004-2006) of Least developed countries in 1976 to that in 1979?
Offer a very short reply. 0.97. What is the ratio of the Production index(2004-2006) of Sri Lanka in 1976 to that in 1979?
Offer a very short reply. 0.8. What is the ratio of the Production index(2004-2006) of Turkey in 1976 to that in 1979?
Offer a terse response. 0.95. What is the ratio of the Production index(2004-2006) of European Union in 1976 to that in 1980?
Provide a short and direct response. 0.9. What is the ratio of the Production index(2004-2006) of Least developed countries in 1976 to that in 1980?
Make the answer very short. 0.93. What is the ratio of the Production index(2004-2006) of Sri Lanka in 1976 to that in 1980?
Offer a terse response. 0.74. What is the ratio of the Production index(2004-2006) in Turkey in 1976 to that in 1980?
Provide a succinct answer. 0.91. What is the ratio of the Production index(2004-2006) in European Union in 1976 to that in 1981?
Your answer should be compact. 0.92. What is the ratio of the Production index(2004-2006) of Least developed countries in 1976 to that in 1981?
Provide a short and direct response. 0.89. What is the ratio of the Production index(2004-2006) of Sri Lanka in 1976 to that in 1981?
Provide a short and direct response. 0.76. What is the ratio of the Production index(2004-2006) of Turkey in 1976 to that in 1981?
Provide a succinct answer. 0.89. What is the ratio of the Production index(2004-2006) of European Union in 1976 to that in 1982?
Your answer should be compact. 0.87. What is the ratio of the Production index(2004-2006) of Least developed countries in 1976 to that in 1982?
Give a very brief answer. 0.88. What is the ratio of the Production index(2004-2006) in Sri Lanka in 1976 to that in 1982?
Ensure brevity in your answer.  0.8. What is the ratio of the Production index(2004-2006) of Turkey in 1976 to that in 1982?
Give a very brief answer. 0.85. What is the ratio of the Production index(2004-2006) in European Union in 1976 to that in 1983?
Your answer should be compact. 0.89. What is the ratio of the Production index(2004-2006) of Least developed countries in 1976 to that in 1983?
Your answer should be compact. 0.86. What is the ratio of the Production index(2004-2006) in Sri Lanka in 1976 to that in 1983?
Offer a terse response. 0.7. What is the ratio of the Production index(2004-2006) of Turkey in 1976 to that in 1983?
Provide a succinct answer. 0.88. What is the ratio of the Production index(2004-2006) of European Union in 1977 to that in 1978?
Ensure brevity in your answer.  0.94. What is the ratio of the Production index(2004-2006) in Least developed countries in 1977 to that in 1978?
Provide a short and direct response. 0.97. What is the ratio of the Production index(2004-2006) of Sri Lanka in 1977 to that in 1978?
Give a very brief answer. 0.94. What is the ratio of the Production index(2004-2006) in Turkey in 1977 to that in 1978?
Your answer should be compact. 0.94. What is the ratio of the Production index(2004-2006) of European Union in 1977 to that in 1979?
Give a very brief answer. 0.91. What is the ratio of the Production index(2004-2006) in Least developed countries in 1977 to that in 1979?
Ensure brevity in your answer.  0.98. What is the ratio of the Production index(2004-2006) of Sri Lanka in 1977 to that in 1979?
Ensure brevity in your answer.  0.82. What is the ratio of the Production index(2004-2006) in Turkey in 1977 to that in 1979?
Give a very brief answer. 0.94. What is the ratio of the Production index(2004-2006) in European Union in 1977 to that in 1980?
Keep it short and to the point. 0.9. What is the ratio of the Production index(2004-2006) of Least developed countries in 1977 to that in 1980?
Provide a succinct answer. 0.94. What is the ratio of the Production index(2004-2006) of Sri Lanka in 1977 to that in 1980?
Your answer should be very brief. 0.76. What is the ratio of the Production index(2004-2006) in Turkey in 1977 to that in 1980?
Provide a succinct answer. 0.9. What is the ratio of the Production index(2004-2006) of European Union in 1977 to that in 1981?
Your response must be concise. 0.92. What is the ratio of the Production index(2004-2006) of Least developed countries in 1977 to that in 1981?
Keep it short and to the point. 0.9. What is the ratio of the Production index(2004-2006) of Sri Lanka in 1977 to that in 1981?
Provide a short and direct response. 0.79. What is the ratio of the Production index(2004-2006) in Turkey in 1977 to that in 1981?
Make the answer very short. 0.88. What is the ratio of the Production index(2004-2006) of European Union in 1977 to that in 1982?
Make the answer very short. 0.87. What is the ratio of the Production index(2004-2006) in Least developed countries in 1977 to that in 1982?
Your answer should be very brief. 0.89. What is the ratio of the Production index(2004-2006) of Sri Lanka in 1977 to that in 1982?
Make the answer very short. 0.83. What is the ratio of the Production index(2004-2006) of Turkey in 1977 to that in 1982?
Ensure brevity in your answer.  0.85. What is the ratio of the Production index(2004-2006) of European Union in 1977 to that in 1983?
Offer a very short reply. 0.89. What is the ratio of the Production index(2004-2006) in Least developed countries in 1977 to that in 1983?
Offer a terse response. 0.87. What is the ratio of the Production index(2004-2006) in Sri Lanka in 1977 to that in 1983?
Keep it short and to the point. 0.72. What is the ratio of the Production index(2004-2006) of Turkey in 1977 to that in 1983?
Your response must be concise. 0.87. What is the ratio of the Production index(2004-2006) of European Union in 1978 to that in 1979?
Your answer should be very brief. 0.96. What is the ratio of the Production index(2004-2006) in Least developed countries in 1978 to that in 1979?
Your answer should be compact. 1.01. What is the ratio of the Production index(2004-2006) in Sri Lanka in 1978 to that in 1979?
Offer a terse response. 0.87. What is the ratio of the Production index(2004-2006) of European Union in 1978 to that in 1980?
Provide a short and direct response. 0.96. What is the ratio of the Production index(2004-2006) in Least developed countries in 1978 to that in 1980?
Keep it short and to the point. 0.97. What is the ratio of the Production index(2004-2006) in Sri Lanka in 1978 to that in 1980?
Give a very brief answer. 0.8. What is the ratio of the Production index(2004-2006) of Turkey in 1978 to that in 1980?
Offer a very short reply. 0.95. What is the ratio of the Production index(2004-2006) of European Union in 1978 to that in 1981?
Keep it short and to the point. 0.98. What is the ratio of the Production index(2004-2006) of Least developed countries in 1978 to that in 1981?
Make the answer very short. 0.93. What is the ratio of the Production index(2004-2006) of Sri Lanka in 1978 to that in 1981?
Provide a succinct answer. 0.83. What is the ratio of the Production index(2004-2006) in Turkey in 1978 to that in 1981?
Keep it short and to the point. 0.94. What is the ratio of the Production index(2004-2006) in European Union in 1978 to that in 1982?
Your response must be concise. 0.93. What is the ratio of the Production index(2004-2006) in Least developed countries in 1978 to that in 1982?
Provide a succinct answer. 0.92. What is the ratio of the Production index(2004-2006) of Sri Lanka in 1978 to that in 1982?
Offer a terse response. 0.88. What is the ratio of the Production index(2004-2006) in Turkey in 1978 to that in 1982?
Keep it short and to the point. 0.9. What is the ratio of the Production index(2004-2006) in European Union in 1978 to that in 1983?
Keep it short and to the point. 0.94. What is the ratio of the Production index(2004-2006) of Least developed countries in 1978 to that in 1983?
Ensure brevity in your answer.  0.9. What is the ratio of the Production index(2004-2006) in Sri Lanka in 1978 to that in 1983?
Offer a terse response. 0.77. What is the ratio of the Production index(2004-2006) of Turkey in 1978 to that in 1983?
Offer a terse response. 0.93. What is the ratio of the Production index(2004-2006) of European Union in 1979 to that in 1980?
Make the answer very short. 1. What is the ratio of the Production index(2004-2006) in Least developed countries in 1979 to that in 1980?
Give a very brief answer. 0.96. What is the ratio of the Production index(2004-2006) of Sri Lanka in 1979 to that in 1980?
Offer a terse response. 0.92. What is the ratio of the Production index(2004-2006) in Turkey in 1979 to that in 1980?
Keep it short and to the point. 0.96. What is the ratio of the Production index(2004-2006) of European Union in 1979 to that in 1981?
Your response must be concise. 1.02. What is the ratio of the Production index(2004-2006) of Least developed countries in 1979 to that in 1981?
Offer a very short reply. 0.92. What is the ratio of the Production index(2004-2006) of Sri Lanka in 1979 to that in 1981?
Make the answer very short. 0.96. What is the ratio of the Production index(2004-2006) in Turkey in 1979 to that in 1981?
Make the answer very short. 0.94. What is the ratio of the Production index(2004-2006) in European Union in 1979 to that in 1982?
Give a very brief answer. 0.96. What is the ratio of the Production index(2004-2006) in Least developed countries in 1979 to that in 1982?
Keep it short and to the point. 0.91. What is the ratio of the Production index(2004-2006) of Sri Lanka in 1979 to that in 1982?
Ensure brevity in your answer.  1.01. What is the ratio of the Production index(2004-2006) in Turkey in 1979 to that in 1982?
Provide a succinct answer. 0.9. What is the ratio of the Production index(2004-2006) of European Union in 1979 to that in 1983?
Provide a short and direct response. 0.98. What is the ratio of the Production index(2004-2006) in Least developed countries in 1979 to that in 1983?
Provide a succinct answer. 0.89. What is the ratio of the Production index(2004-2006) in Sri Lanka in 1979 to that in 1983?
Your answer should be very brief. 0.88. What is the ratio of the Production index(2004-2006) of Turkey in 1979 to that in 1983?
Provide a short and direct response. 0.93. What is the ratio of the Production index(2004-2006) in European Union in 1980 to that in 1981?
Keep it short and to the point. 1.02. What is the ratio of the Production index(2004-2006) of Least developed countries in 1980 to that in 1981?
Keep it short and to the point. 0.96. What is the ratio of the Production index(2004-2006) in Sri Lanka in 1980 to that in 1981?
Your answer should be very brief. 1.04. What is the ratio of the Production index(2004-2006) in Turkey in 1980 to that in 1981?
Provide a succinct answer. 0.98. What is the ratio of the Production index(2004-2006) of European Union in 1980 to that in 1982?
Offer a very short reply. 0.97. What is the ratio of the Production index(2004-2006) of Least developed countries in 1980 to that in 1982?
Give a very brief answer. 0.95. What is the ratio of the Production index(2004-2006) in Sri Lanka in 1980 to that in 1982?
Provide a succinct answer. 1.09. What is the ratio of the Production index(2004-2006) in Turkey in 1980 to that in 1982?
Keep it short and to the point. 0.94. What is the ratio of the Production index(2004-2006) of European Union in 1980 to that in 1983?
Your answer should be compact. 0.98. What is the ratio of the Production index(2004-2006) in Least developed countries in 1980 to that in 1983?
Your response must be concise. 0.93. What is the ratio of the Production index(2004-2006) of Sri Lanka in 1980 to that in 1983?
Your response must be concise. 0.96. What is the ratio of the Production index(2004-2006) of Turkey in 1980 to that in 1983?
Provide a succinct answer. 0.97. What is the ratio of the Production index(2004-2006) in European Union in 1981 to that in 1982?
Provide a short and direct response. 0.95. What is the ratio of the Production index(2004-2006) in Least developed countries in 1981 to that in 1982?
Keep it short and to the point. 0.98. What is the ratio of the Production index(2004-2006) in Sri Lanka in 1981 to that in 1982?
Keep it short and to the point. 1.05. What is the ratio of the Production index(2004-2006) in Turkey in 1981 to that in 1982?
Give a very brief answer. 0.96. What is the ratio of the Production index(2004-2006) in Sri Lanka in 1981 to that in 1983?
Make the answer very short. 0.92. What is the ratio of the Production index(2004-2006) in Turkey in 1981 to that in 1983?
Provide a succinct answer. 0.99. What is the ratio of the Production index(2004-2006) of European Union in 1982 to that in 1983?
Provide a short and direct response. 1.02. What is the ratio of the Production index(2004-2006) in Least developed countries in 1982 to that in 1983?
Provide a succinct answer. 0.98. What is the ratio of the Production index(2004-2006) of Sri Lanka in 1982 to that in 1983?
Make the answer very short. 0.88. What is the ratio of the Production index(2004-2006) of Turkey in 1982 to that in 1983?
Keep it short and to the point. 1.03. What is the difference between the highest and the second highest Production index(2004-2006) of European Union?
Ensure brevity in your answer.  1.45. What is the difference between the highest and the second highest Production index(2004-2006) of Least developed countries?
Make the answer very short. 1.26. What is the difference between the highest and the second highest Production index(2004-2006) in Sri Lanka?
Keep it short and to the point. 4.07. What is the difference between the highest and the second highest Production index(2004-2006) in Turkey?
Provide a short and direct response. 2.05. What is the difference between the highest and the lowest Production index(2004-2006) of European Union?
Offer a very short reply. 12.43. What is the difference between the highest and the lowest Production index(2004-2006) in Least developed countries?
Give a very brief answer. 7.78. What is the difference between the highest and the lowest Production index(2004-2006) in Sri Lanka?
Provide a short and direct response. 27.09. What is the difference between the highest and the lowest Production index(2004-2006) in Turkey?
Offer a terse response. 10.1. 